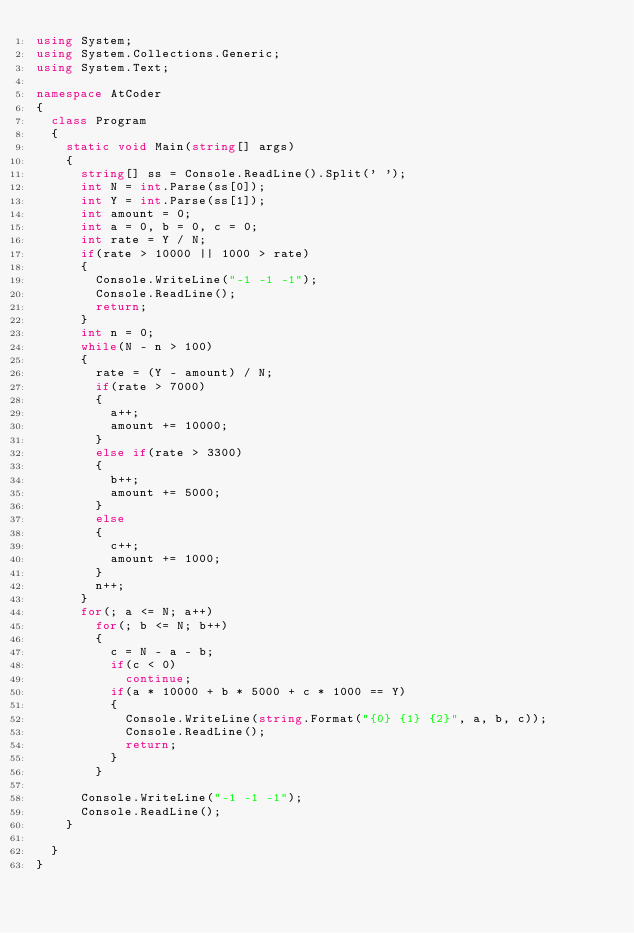Convert code to text. <code><loc_0><loc_0><loc_500><loc_500><_C#_>using System;
using System.Collections.Generic;
using System.Text;

namespace AtCoder
{
  class Program
  {
    static void Main(string[] args)
    {
      string[] ss = Console.ReadLine().Split(' ');
      int N = int.Parse(ss[0]);
      int Y = int.Parse(ss[1]);
      int amount = 0;
      int a = 0, b = 0, c = 0;
      int rate = Y / N;
      if(rate > 10000 || 1000 > rate)
      {
        Console.WriteLine("-1 -1 -1");
        Console.ReadLine();
        return;
      }
      int n = 0;
      while(N - n > 100)
      {
        rate = (Y - amount) / N;
        if(rate > 7000)
        {
          a++;
          amount += 10000;
        }
        else if(rate > 3300)
        {
          b++;
          amount += 5000;
        }
        else
        {
          c++;
          amount += 1000;
        }
        n++;
      }
      for(; a <= N; a++)
        for(; b <= N; b++)
        {
          c = N - a - b;
          if(c < 0)
            continue;
          if(a * 10000 + b * 5000 + c * 1000 == Y)
          {
            Console.WriteLine(string.Format("{0} {1} {2}", a, b, c));
            Console.ReadLine();
            return;
          }
        }

      Console.WriteLine("-1 -1 -1");
      Console.ReadLine();
    }

  }
}</code> 